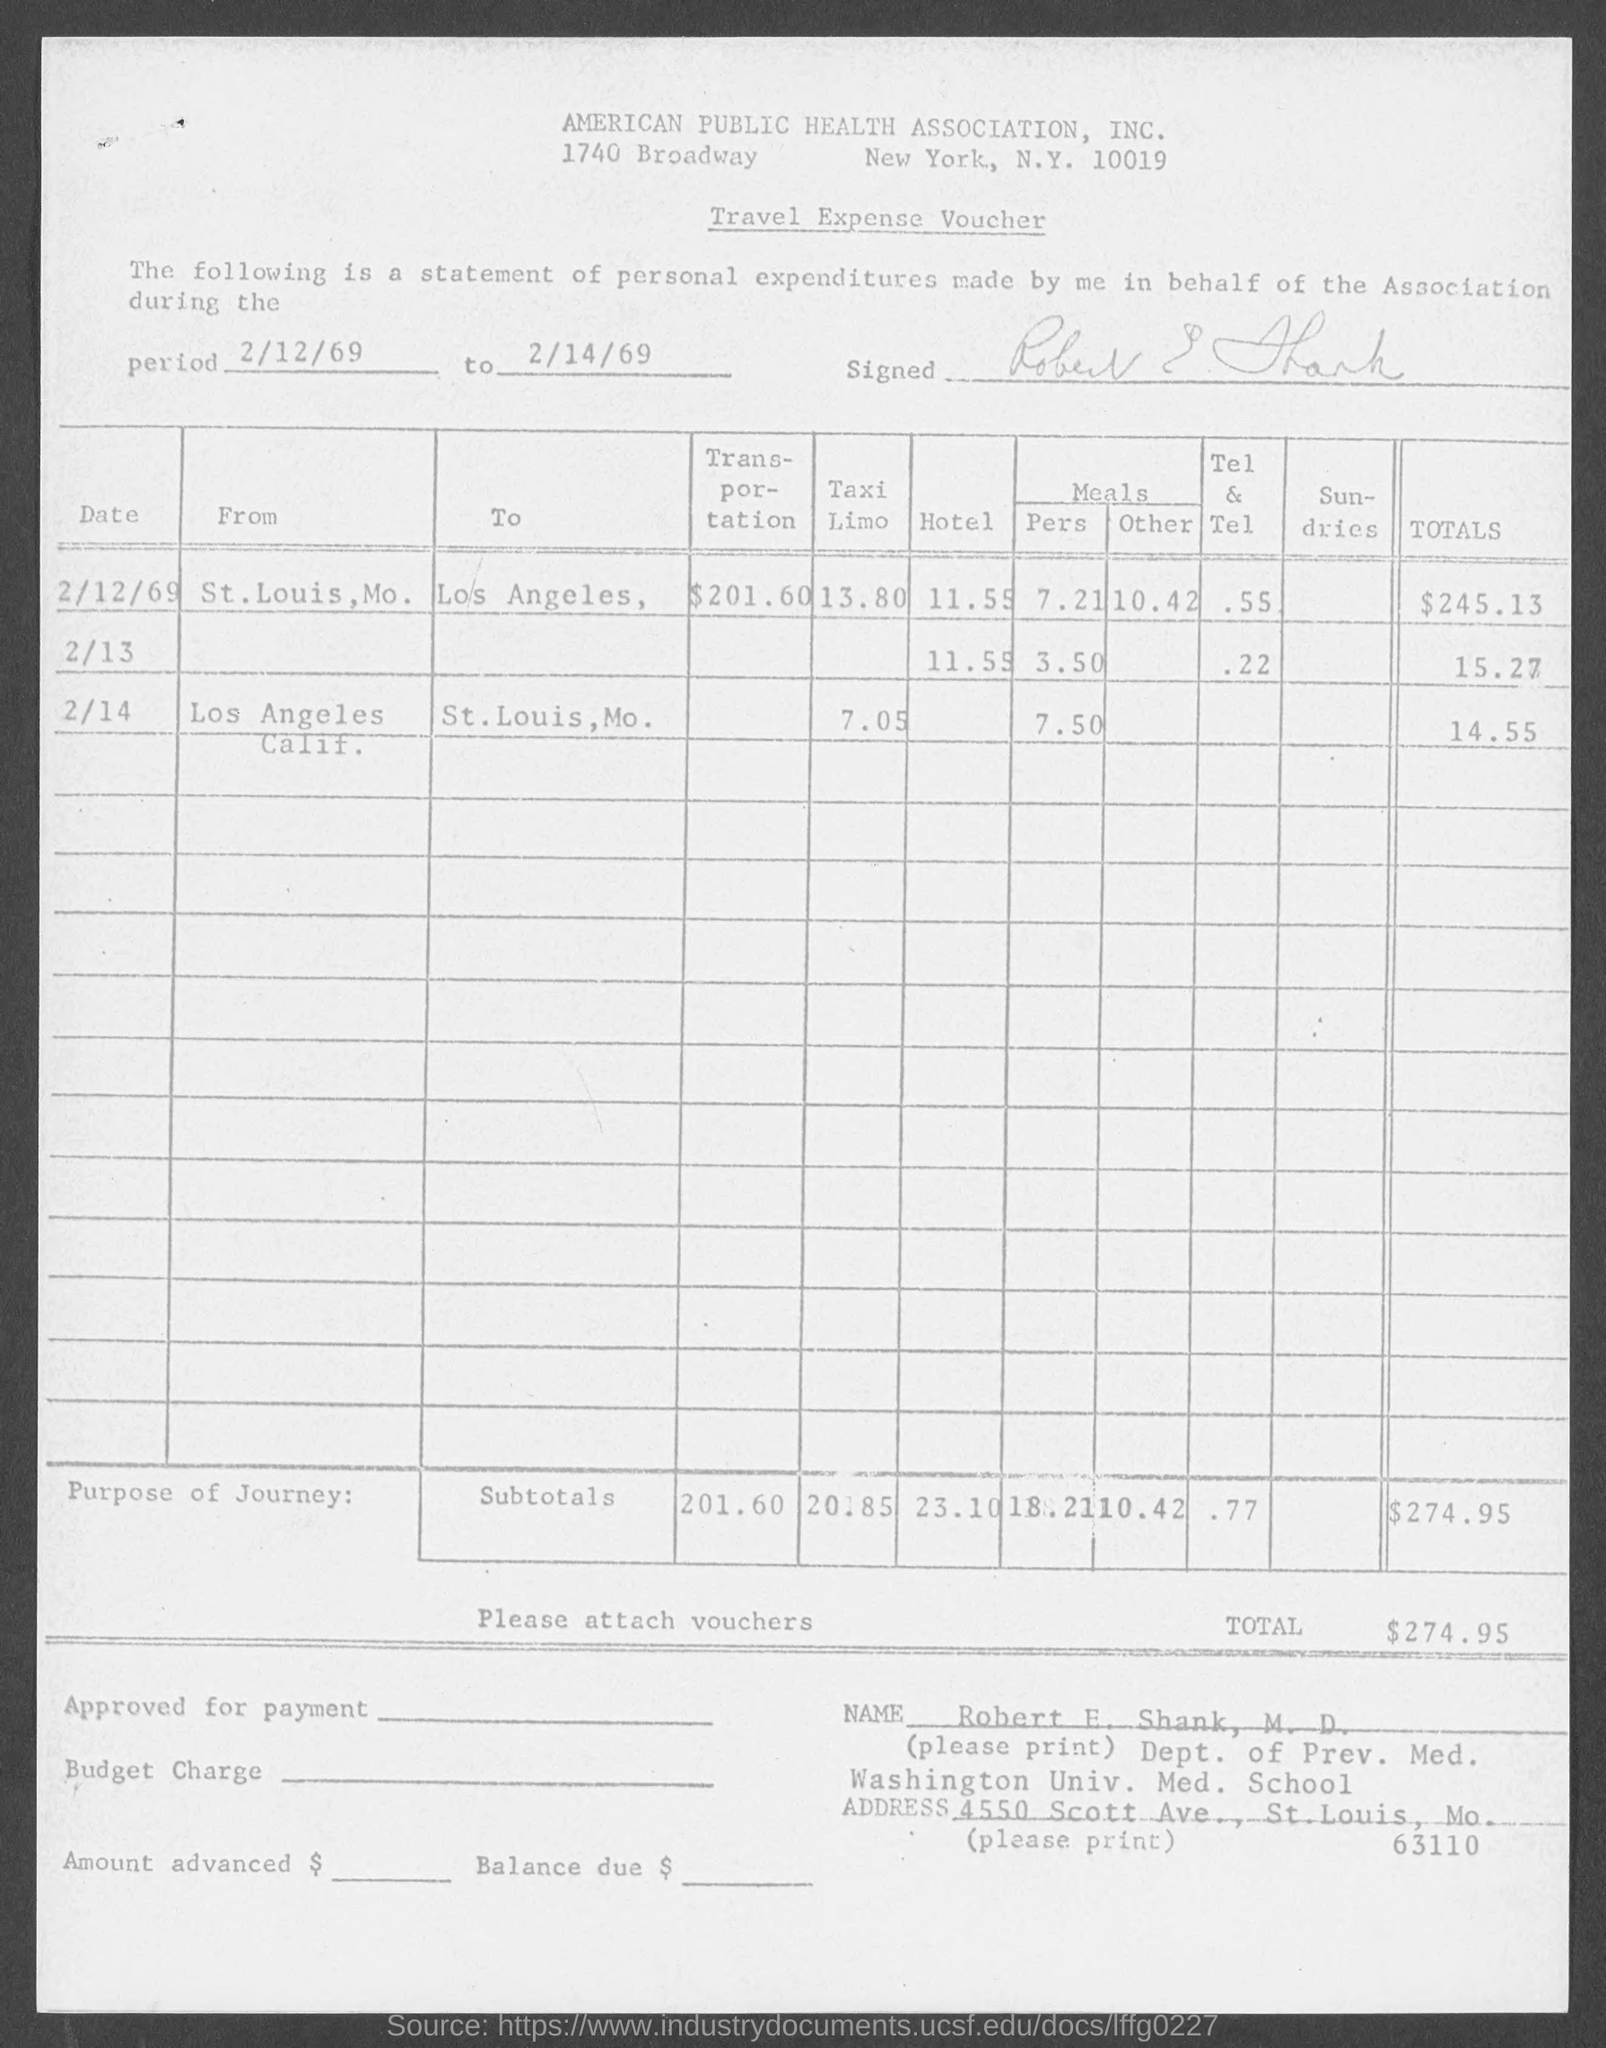What is the Period of Travel Expense Voucher ?
Keep it short and to the point. 2/12/69 to 2/14/69. What is the Transportation Expenses by St. Louis , Mo.
Make the answer very short. 201.60. How much is the total on 2/12/69 ?
Your response must be concise. 245.13. How much is the total on 2/13 ?
Keep it short and to the point. 15.27. How much is the total on 2/14 ?
Keep it short and to the point. 14.55. 